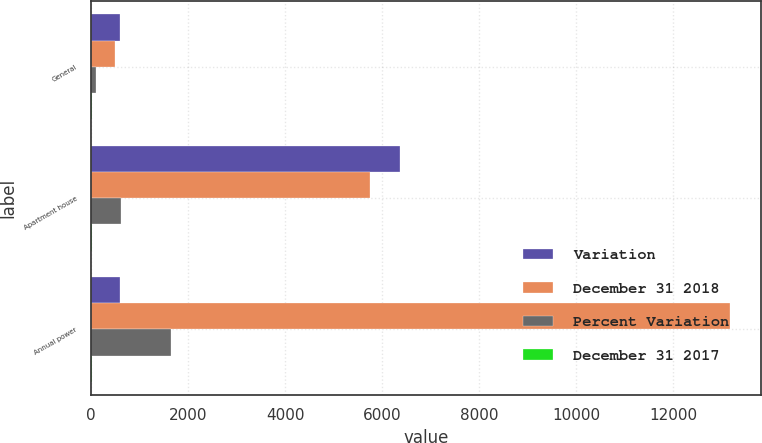<chart> <loc_0><loc_0><loc_500><loc_500><stacked_bar_chart><ecel><fcel>General<fcel>Apartment house<fcel>Annual power<nl><fcel>Variation<fcel>593<fcel>6358<fcel>593<nl><fcel>December 31 2018<fcel>490<fcel>5754<fcel>13166<nl><fcel>Percent Variation<fcel>103<fcel>604<fcel>1645<nl><fcel>December 31 2017<fcel>21<fcel>10.5<fcel>12.5<nl></chart> 